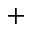<formula> <loc_0><loc_0><loc_500><loc_500>^ { + }</formula> 